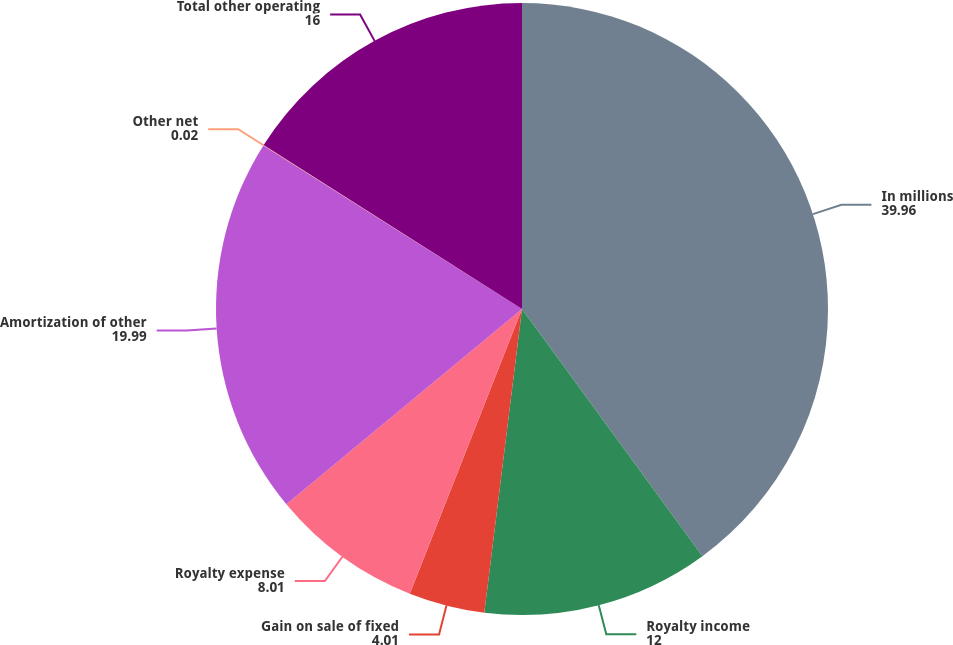<chart> <loc_0><loc_0><loc_500><loc_500><pie_chart><fcel>In millions<fcel>Royalty income<fcel>Gain on sale of fixed<fcel>Royalty expense<fcel>Amortization of other<fcel>Other net<fcel>Total other operating<nl><fcel>39.96%<fcel>12.0%<fcel>4.01%<fcel>8.01%<fcel>19.99%<fcel>0.02%<fcel>16.0%<nl></chart> 